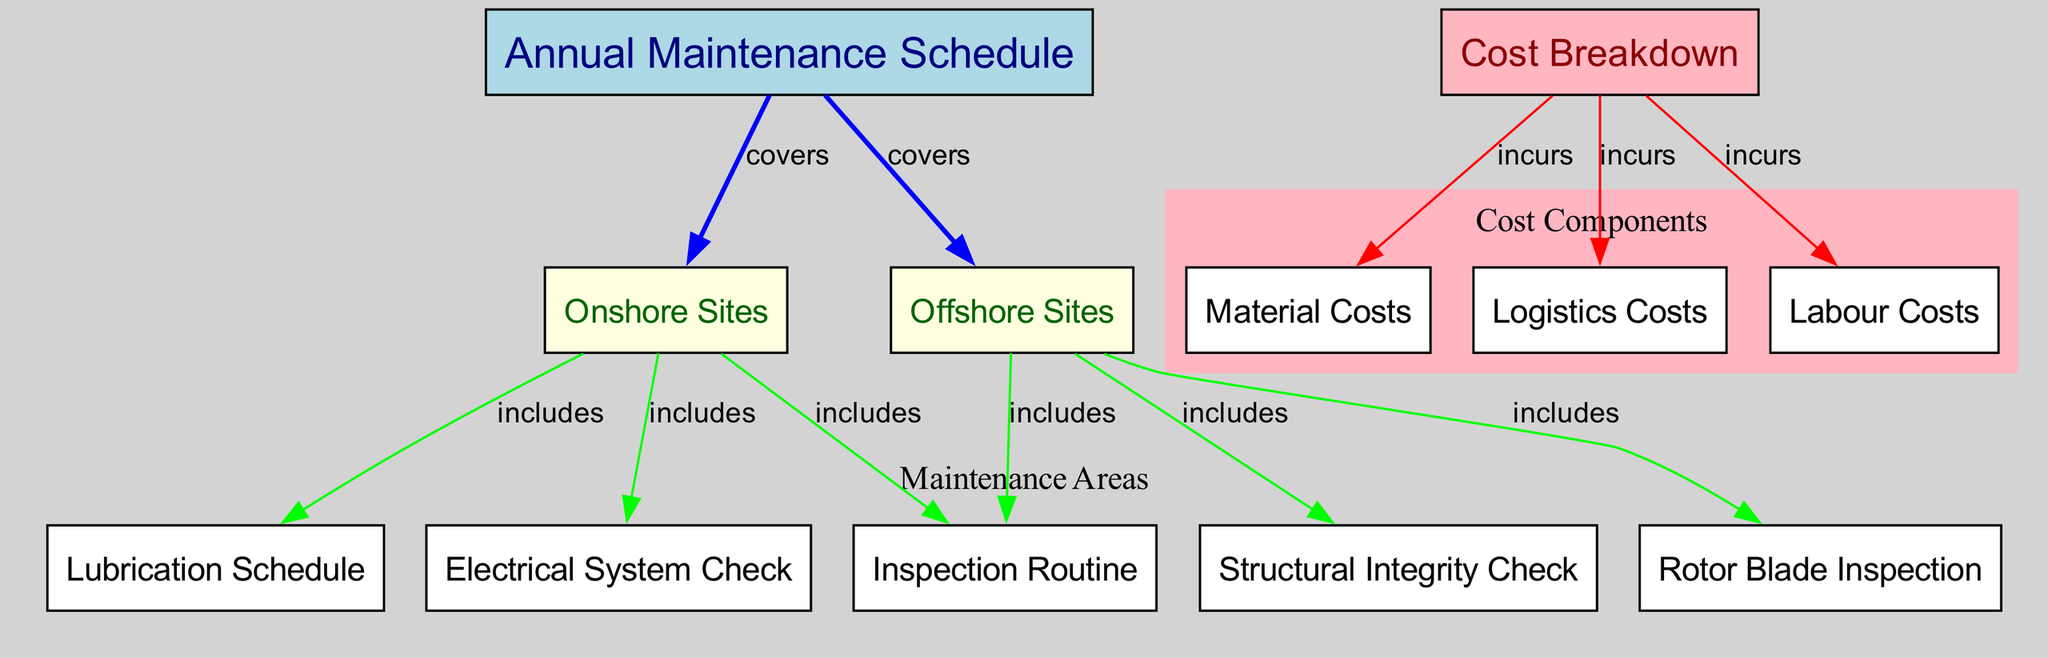What does the "Annual Maintenance Schedule" cover? The "Annual Maintenance Schedule" is connected to both "Onshore Sites" and "Offshore Sites," indicating that it encompasses maintenance for both site types.
Answer: Onshore Sites and Offshore Sites How many maintenance areas are included in the onshore sites? The "Onshore Sites" node includes three maintenance areas: "Inspection Routine," "Lubrication Schedule," and "Electrical System Check," which can be counted directly from the edges linked to this node.
Answer: 3 Which cost component does the "Cost Breakdown" incur? The "Cost Breakdown" has edges leading to "Labour Costs," "Material Costs," and "Logistics Costs," indicating that it incurs all three types of costs.
Answer: Labour Costs, Material Costs, Logistics Costs Which maintenance check is specific to offshore sites? The "Structural Integrity Check" and "Rotor Blade Inspection" are included under the "Offshore Sites" node, thus pointing to their specificity to offshore maintenance.
Answer: Structural Integrity Check, Rotor Blade Inspection What maintenance tasks are included in offshore sites? The "Offshore Sites" node includes a structural integrity check and rotor blade inspection, while all nodes included also have inspection tasks associated with them, leading to this specific identification.
Answer: Structural Integrity Check, Rotor Blade Inspection How many total nodes are present in the diagram? By counting all nodes defined in the initial data, we find that there are twelve nodes in total.
Answer: 12 What type of check is not listed under onshore sites? The "Structural Integrity Check" and "Rotor Blade Inspection" are absent from the "Onshore Sites" maintenance area, as these tasks appear only in the offshore context.
Answer: Structural Integrity Check, Rotor Blade Inspection What color represents the "Cost Breakdown"? The "Cost Breakdown" is represented in light pink color as indicated by the node styling.
Answer: Light pink What is the primary node type representing maintenance schedules? The primary node representing maintenance schedules is identified as "Annual Maintenance Schedule," which serves as the root of the diagram concerning maintenance.
Answer: Annual Maintenance Schedule 